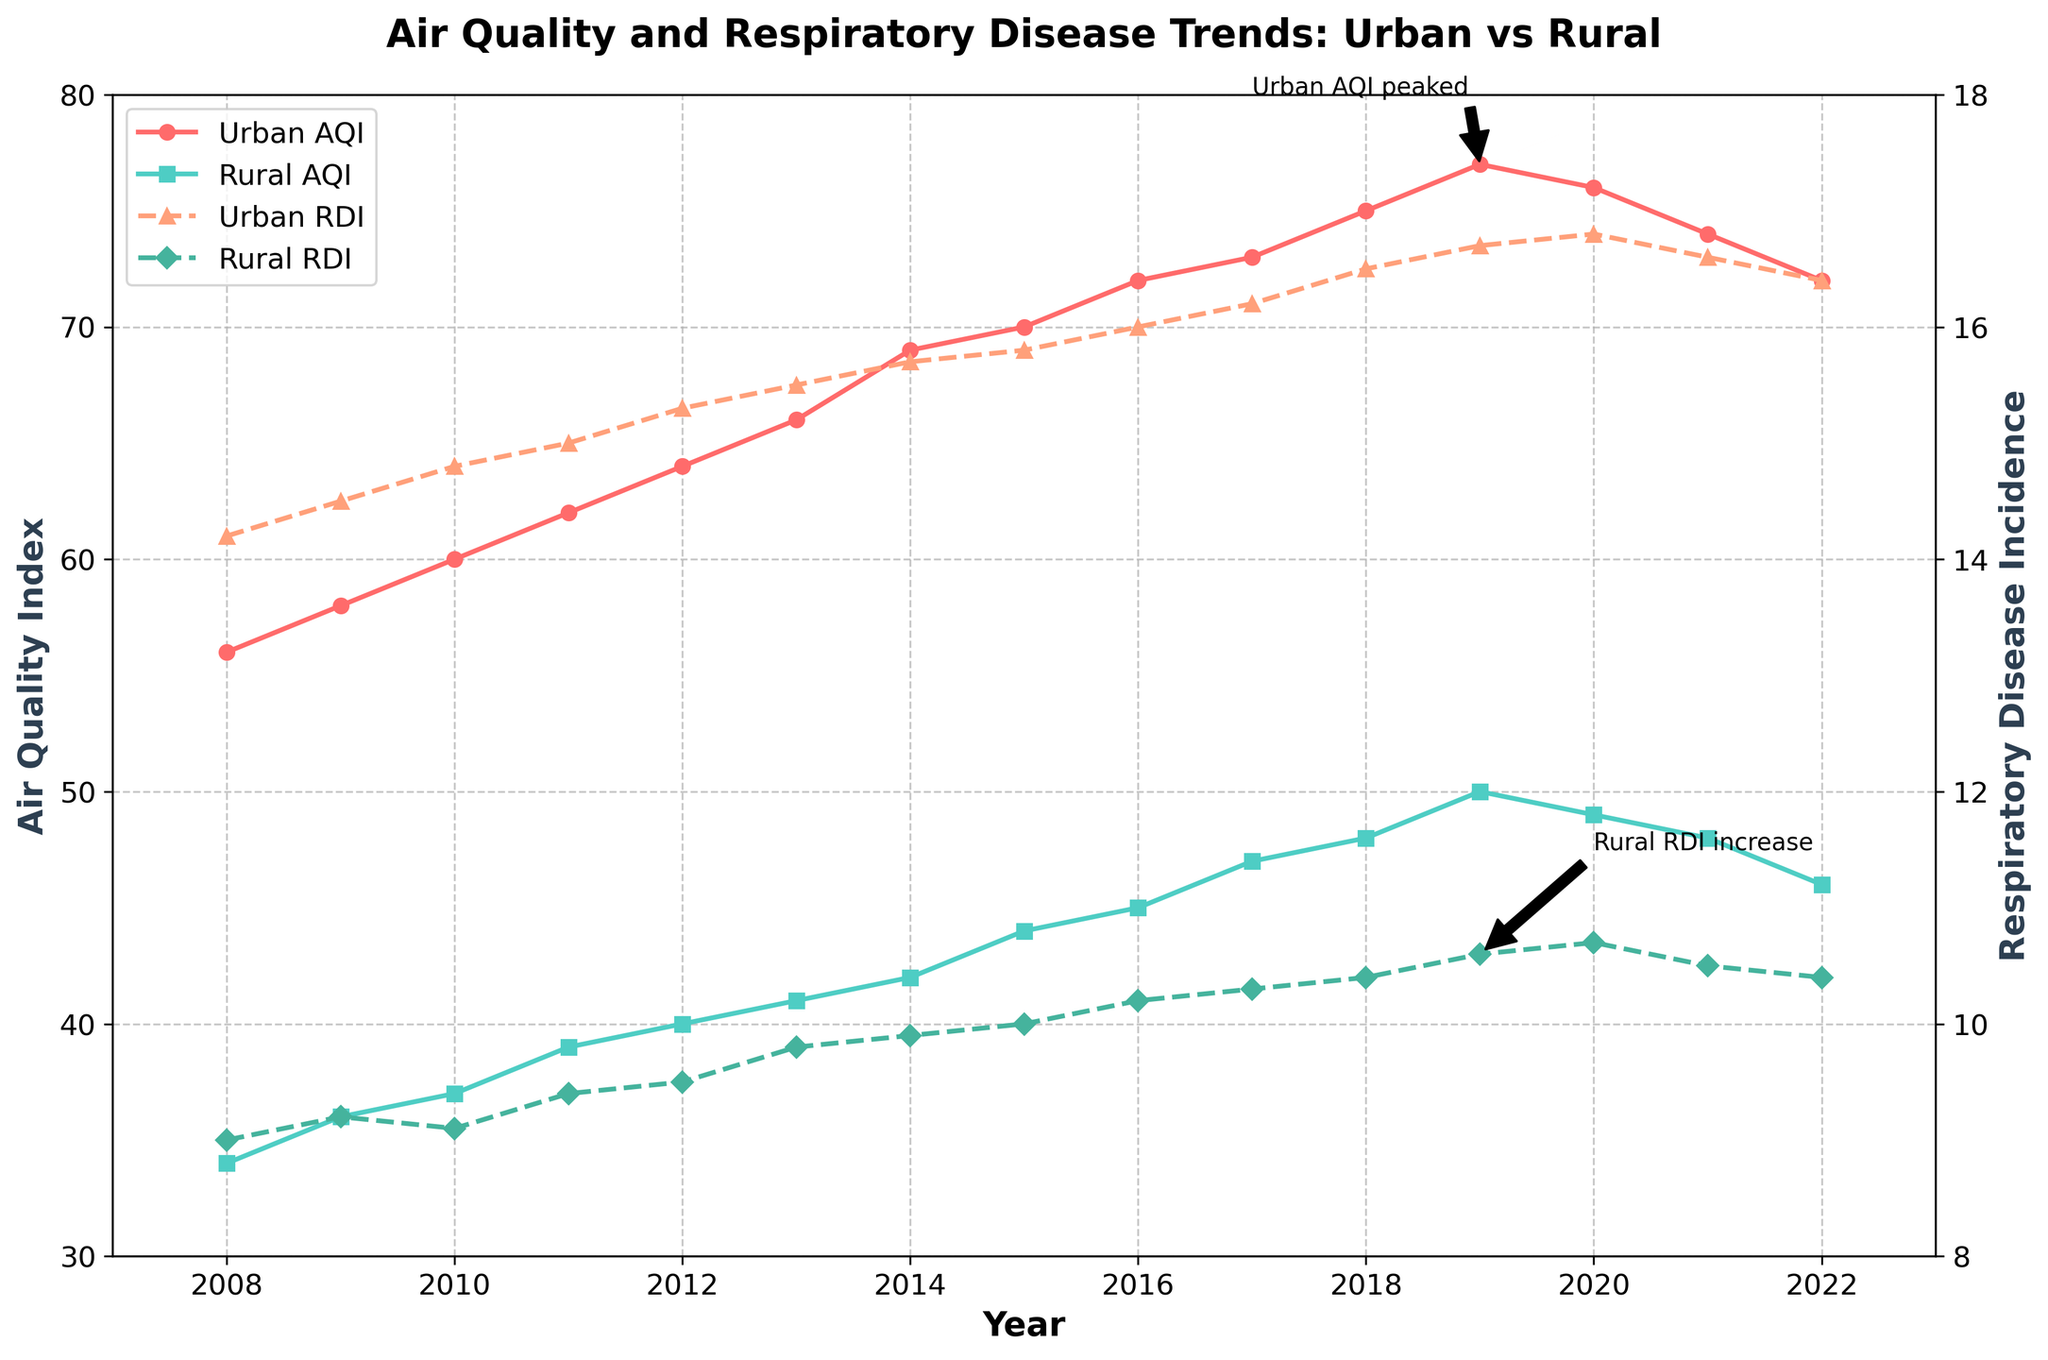What is the title of the figure? The title is usually placed at the top of the figure in a larger or bold font to quickly convey the main topic of the plot. Here, the title is "Air Quality and Respiratory Disease Trends: Urban vs Rural".
Answer: Air Quality and Respiratory Disease Trends: Urban vs Rural Which location had the highest Air Quality Index (AQI) in 2019? To find the highest AQI in 2019, look at the AQI values for both locations in that year. The values should be compared for New York City and Albany in 2019. According to the plot, New York City had an AQI of 77, which is higher than Albany's AQI of 50.
Answer: New York City What's the trend of respiratory disease incidence in rural areas from 2008 to 2022? To determine the trend, observe the direction of the line plot for rural respiratory disease incidence (RDI) over the years 2008 to 2022. The figure shows an overall upward trend with a slight decline after 2020.
Answer: Upward trend How did the urban AQI change from its peak in 2019 to 2022? Find the values of urban AQI at its peak in 2019 (77) and its value in 2022 (72), then calculate the difference to determine the change.
Answer: Decreased by 5 Which had a higher increase in respiratory disease incidence from 2008 to 2022, urban or rural areas? Calculate the difference in respiratory disease incidence for urban areas in 2022 (16.4) and 2008 (14.2), and for rural areas in 2022 (10.4) and 2008 (9.0), then compare the two differences. Urban: 16.4 - 14.2 = 2.2, Rural: 10.4 - 9.0 = 1.4; thus, the urban area had a higher increase.
Answer: Urban areas Is there any notable pattern in the data related to respiratory disease incidence in urban areas post-2018? Look at the trend line for urban respiratory disease incidence post-2018. The figure shows a peak in 2020, followed by a slight decrease in the following years (2021-2022).
Answer: Yes, a peak in 2020 followed by a slight decrease What are the colors used to represent urban and rural Air Quality Index? Refer to the colors of the lines representing urban and rural AQI in the figure. Urban AQI is represented by a red line and rural AQI by a teal line.
Answer: Red for urban, teal for rural In which year did the urban area experience the steepest increase in AQI? Identify the year-on-year changes in the AQI for the urban area and find the largest increase. The steepest increase occurred between 2018 (75) and 2019 (77), an increase of 2.
Answer: 2019 How does the respiratory disease incidence (RDI) in urban areas compare to rural areas in 2020? Compare the RDI values for urban (16.8) and rural (10.7) areas in 2020 from the plot. Urban RDI is significantly higher than rural RDI.
Answer: Urban RDI is higher What annotation is used to highlight a significant point in the rural RDI trend? Look for text annotations with arrows indicating specific points on the graph. The annotation states "Rural RDI increase" pointing to 2019.
Answer: Rural RDI increase 